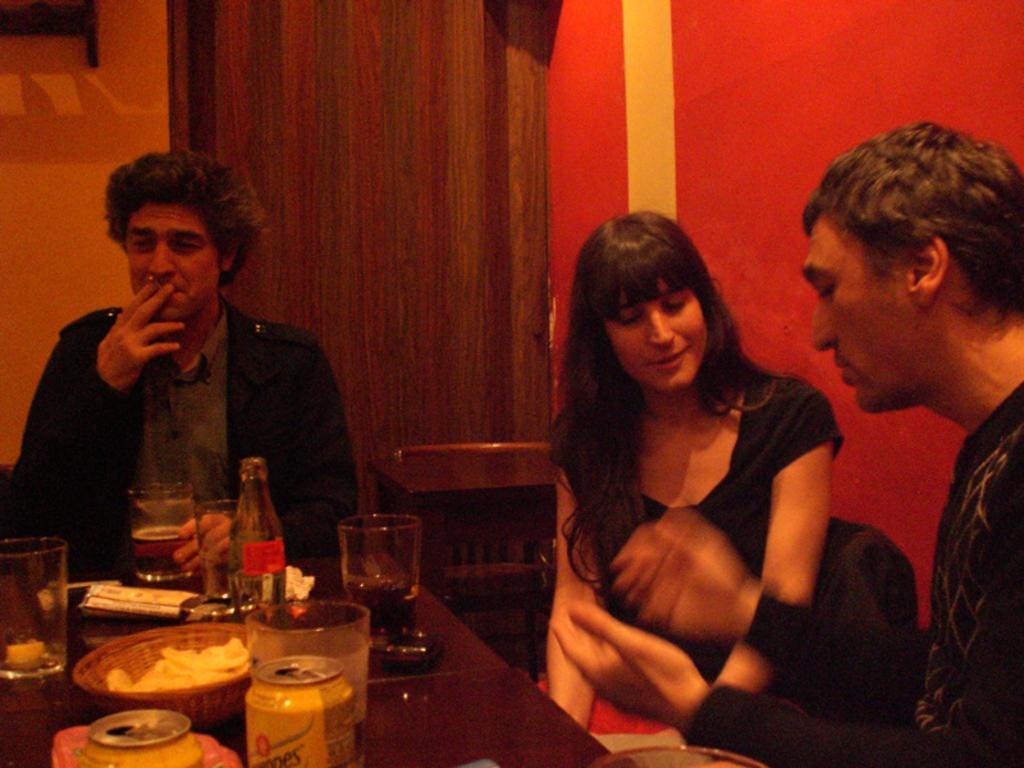How would you summarize this image in a sentence or two? Here we can see three persons are sitting on the chairs. This is table. On the table there are glasses, bottle, tin, and a bowl. On the background there is a wall and this is door. 